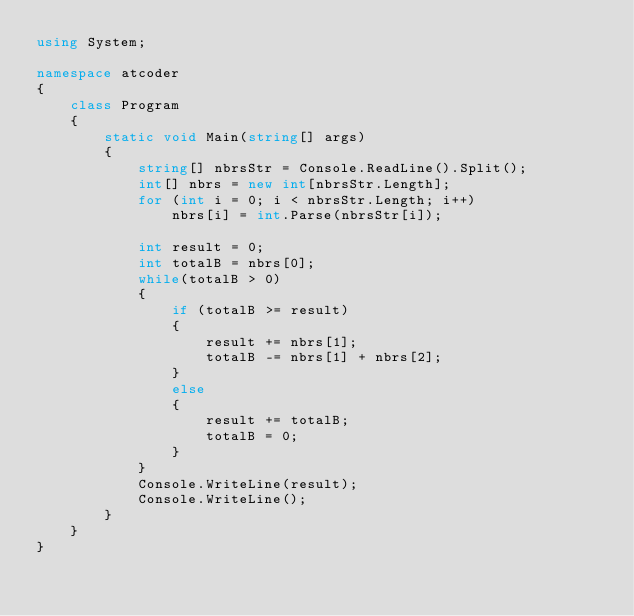Convert code to text. <code><loc_0><loc_0><loc_500><loc_500><_C#_>using System;

namespace atcoder
{
    class Program
    {
        static void Main(string[] args)
        {
            string[] nbrsStr = Console.ReadLine().Split();
            int[] nbrs = new int[nbrsStr.Length];
            for (int i = 0; i < nbrsStr.Length; i++)
                nbrs[i] = int.Parse(nbrsStr[i]);

            int result = 0;
            int totalB = nbrs[0];
            while(totalB > 0)
            {
                if (totalB >= result)
                {
                    result += nbrs[1];
                    totalB -= nbrs[1] + nbrs[2];
                }
                else
                {
                    result += totalB;
                    totalB = 0;
                }
            }
            Console.WriteLine(result);
            Console.WriteLine();
        }
    }
}
</code> 